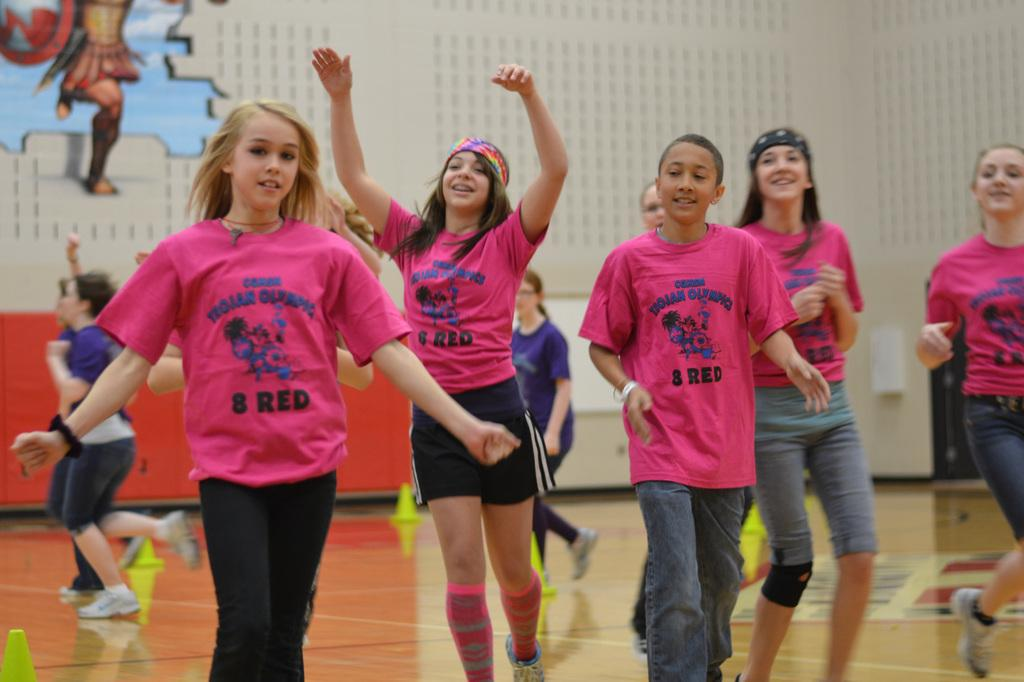What objects are on the floor in the image? There are green cones on the floor in the image. Can you describe the people visible in the image? There are people visible in the image, but their specific actions or characteristics are not mentioned in the provided facts. What is present in the background of the image? A person's board is present in the background of the image. How many dimes can be seen on the window in the image? There is no window or dimes present in the image. What historical event is depicted in the image? The provided facts do not mention any historical event or context, so it cannot be determined from the image. 